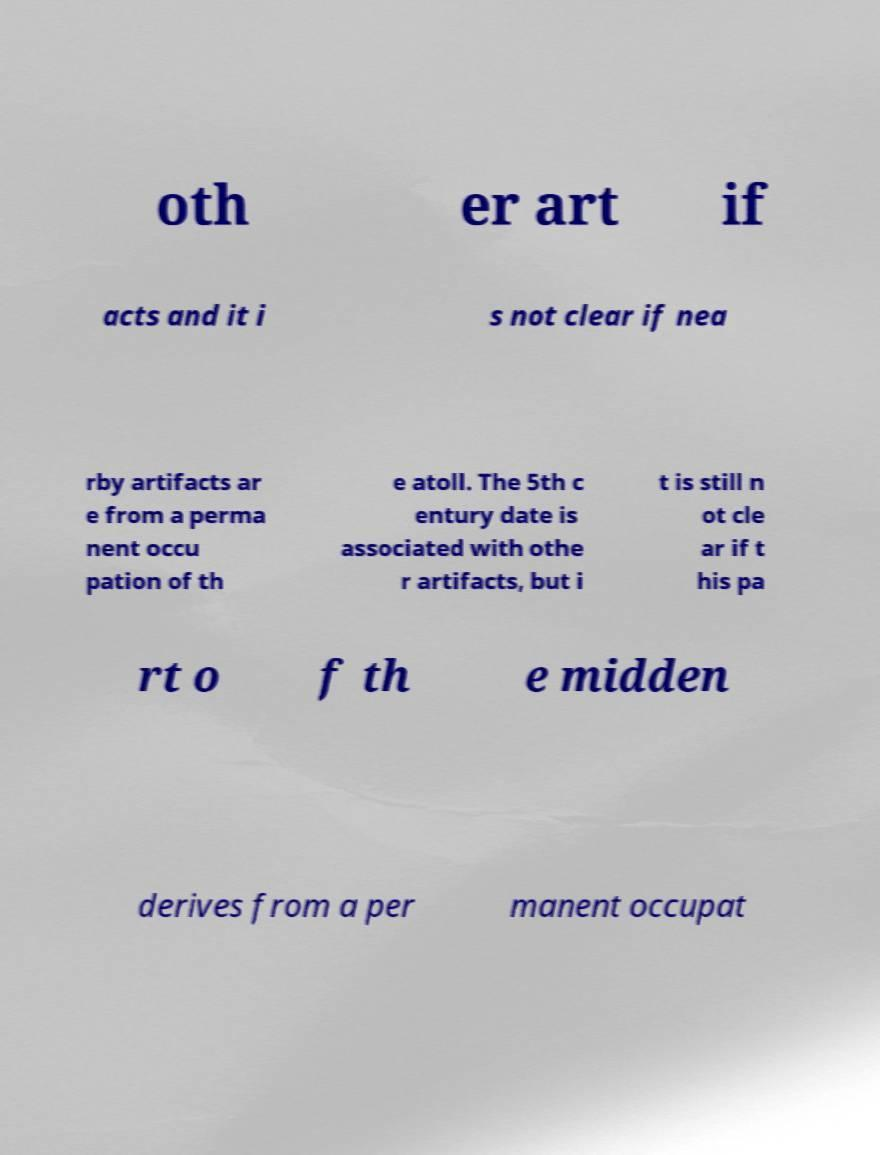What messages or text are displayed in this image? I need them in a readable, typed format. oth er art if acts and it i s not clear if nea rby artifacts ar e from a perma nent occu pation of th e atoll. The 5th c entury date is associated with othe r artifacts, but i t is still n ot cle ar if t his pa rt o f th e midden derives from a per manent occupat 